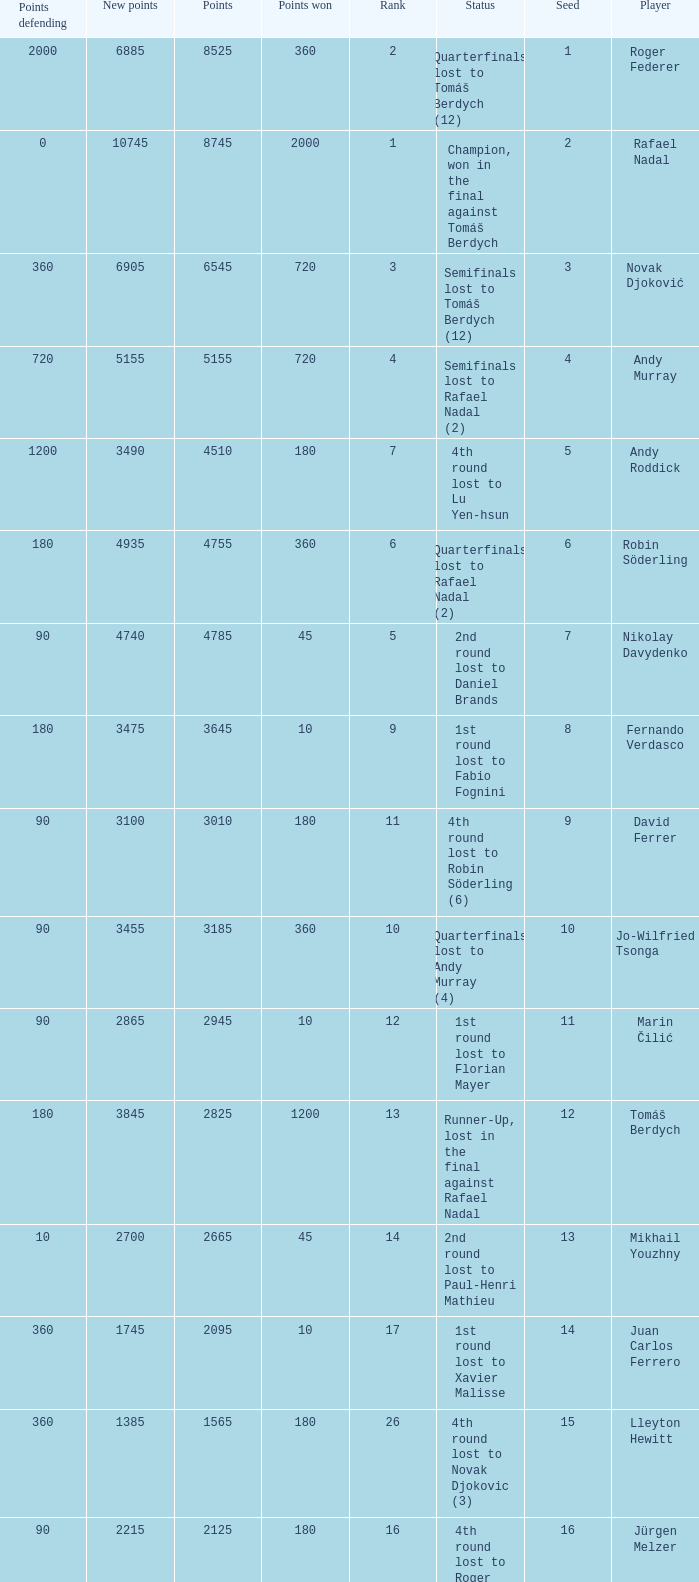Name the number of points defending for 1075 1.0. 